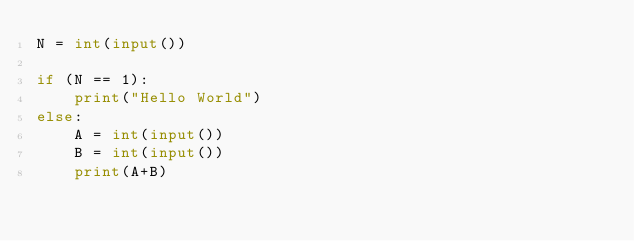<code> <loc_0><loc_0><loc_500><loc_500><_Python_>N = int(input())

if (N == 1):
    print("Hello World")
else:
    A = int(input())
    B = int(input())
    print(A+B)</code> 